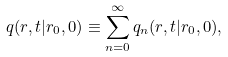Convert formula to latex. <formula><loc_0><loc_0><loc_500><loc_500>q ( r , t | r _ { 0 } , 0 ) \equiv \sum _ { n = 0 } ^ { \infty } q _ { n } ( r , t | r _ { 0 } , 0 ) ,</formula> 